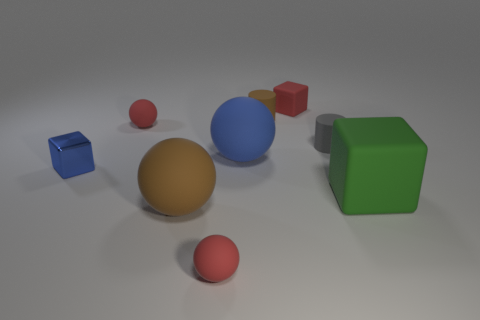Are there any other things that are the same size as the brown rubber cylinder?
Your answer should be very brief. Yes. Is the number of big brown spheres that are behind the small brown cylinder greater than the number of large balls?
Give a very brief answer. No. There is a tiny red thing that is behind the brown cylinder that is to the left of the matte thing that is to the right of the gray cylinder; what shape is it?
Provide a short and direct response. Cube. Does the rubber block behind the green rubber cube have the same size as the green rubber block?
Your answer should be compact. No. The small red rubber thing that is to the right of the large brown sphere and in front of the small brown matte object has what shape?
Keep it short and to the point. Sphere. Does the tiny metallic block have the same color as the matte object that is in front of the brown rubber sphere?
Offer a very short reply. No. What is the color of the matte block on the left side of the large rubber block on the right side of the tiny rubber cylinder on the left side of the tiny gray matte thing?
Your answer should be compact. Red. There is another rubber thing that is the same shape as the green rubber thing; what is its color?
Provide a succinct answer. Red. Are there the same number of tiny brown things in front of the small gray thing and tiny cubes?
Provide a short and direct response. No. What number of balls are either metallic objects or blue rubber objects?
Your response must be concise. 1. 